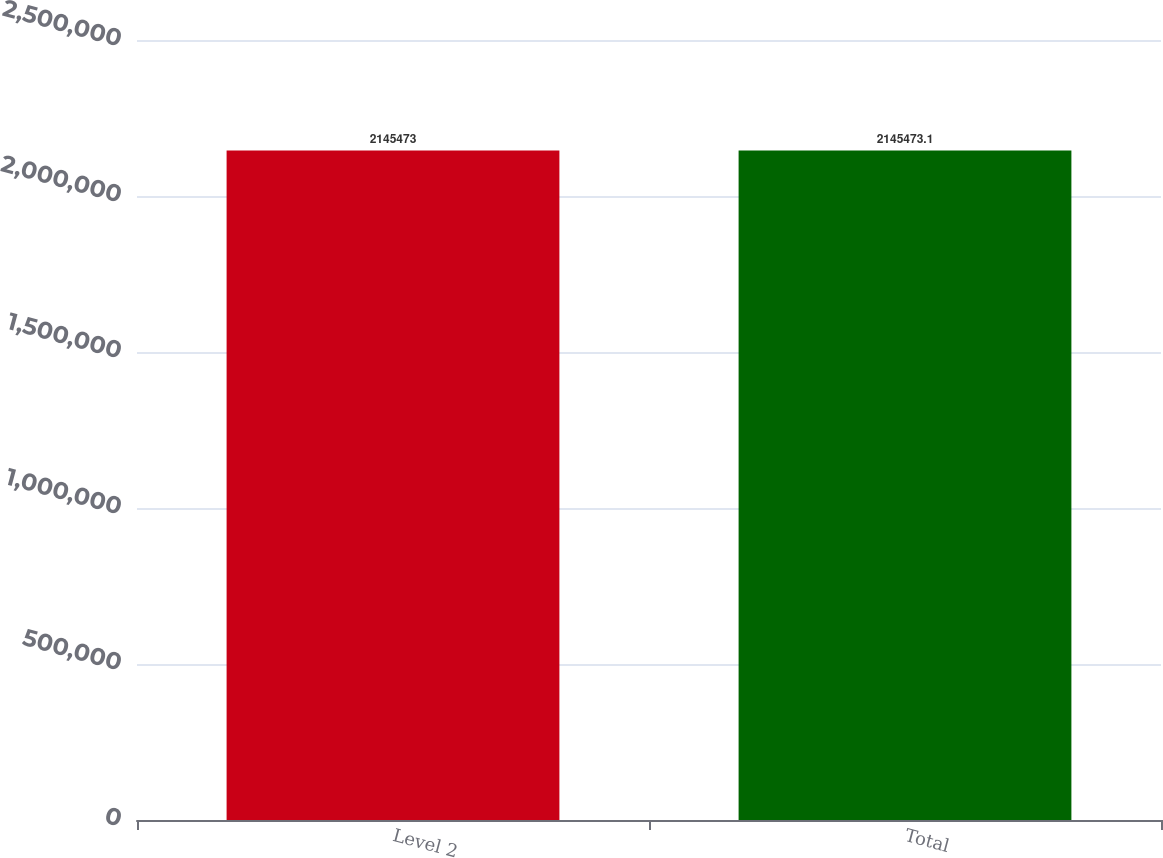Convert chart. <chart><loc_0><loc_0><loc_500><loc_500><bar_chart><fcel>Level 2<fcel>Total<nl><fcel>2.14547e+06<fcel>2.14547e+06<nl></chart> 